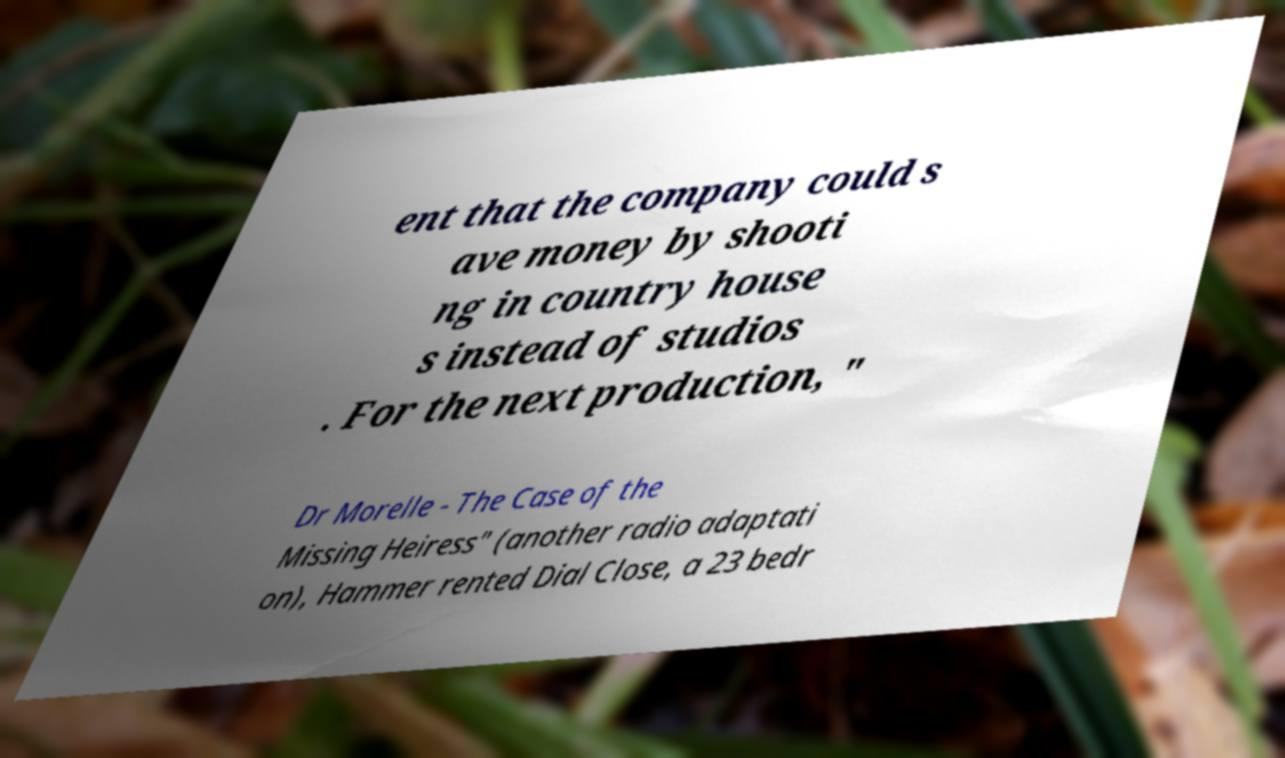Could you assist in decoding the text presented in this image and type it out clearly? ent that the company could s ave money by shooti ng in country house s instead of studios . For the next production, " Dr Morelle - The Case of the Missing Heiress" (another radio adaptati on), Hammer rented Dial Close, a 23 bedr 